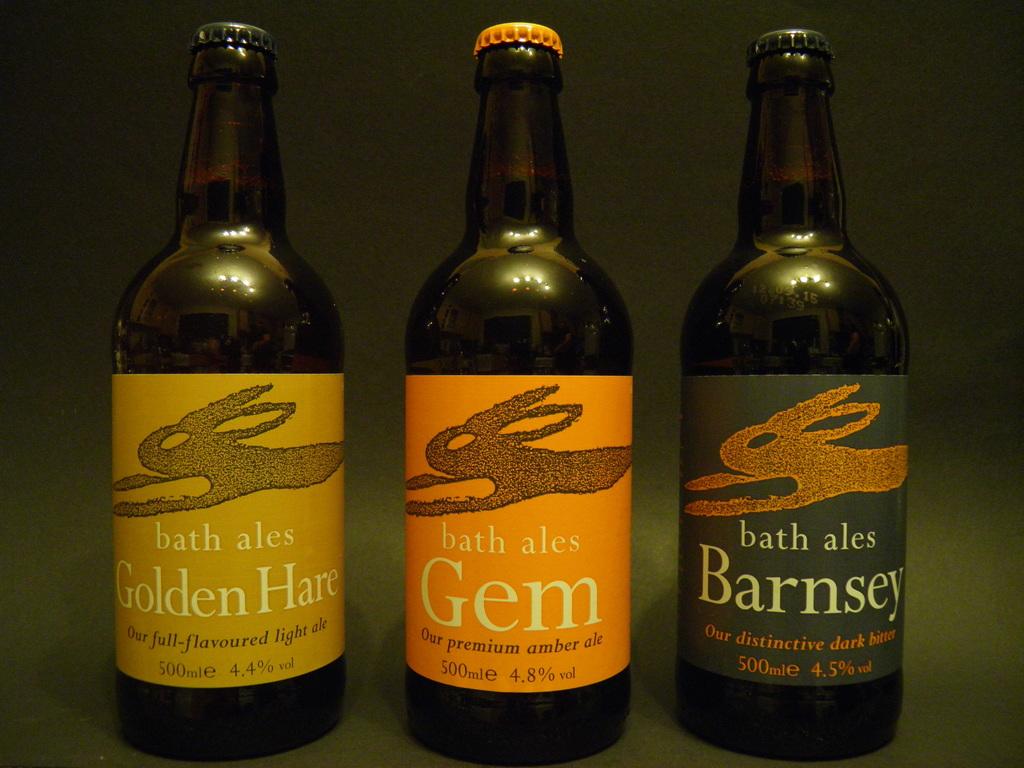What is bath ales' description of their drink called gem?
Make the answer very short. Our premium amber ale. 